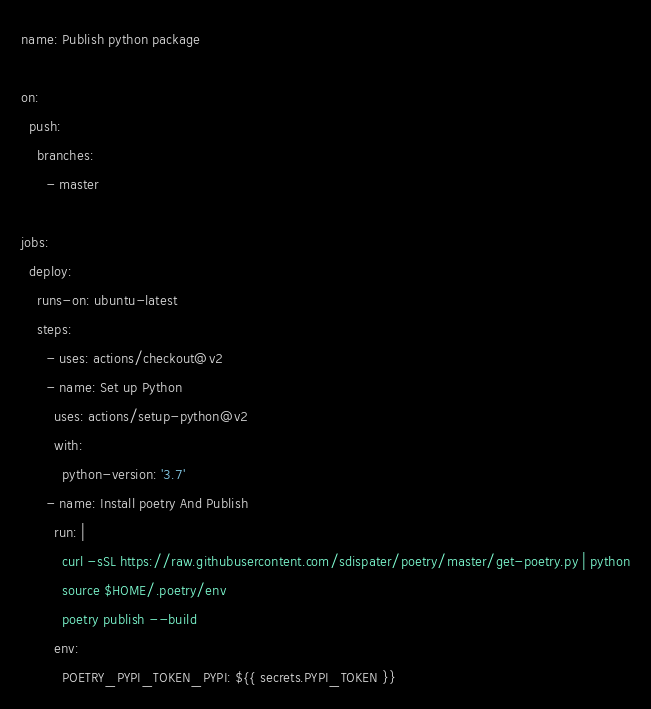<code> <loc_0><loc_0><loc_500><loc_500><_YAML_>name: Publish python package

on:
  push:
    branches:
      - master

jobs:
  deploy:
    runs-on: ubuntu-latest
    steps:
      - uses: actions/checkout@v2
      - name: Set up Python
        uses: actions/setup-python@v2
        with:
          python-version: '3.7'
      - name: Install poetry And Publish
        run: |
          curl -sSL https://raw.githubusercontent.com/sdispater/poetry/master/get-poetry.py | python
          source $HOME/.poetry/env
          poetry publish --build
        env:
          POETRY_PYPI_TOKEN_PYPI: ${{ secrets.PYPI_TOKEN }}</code> 